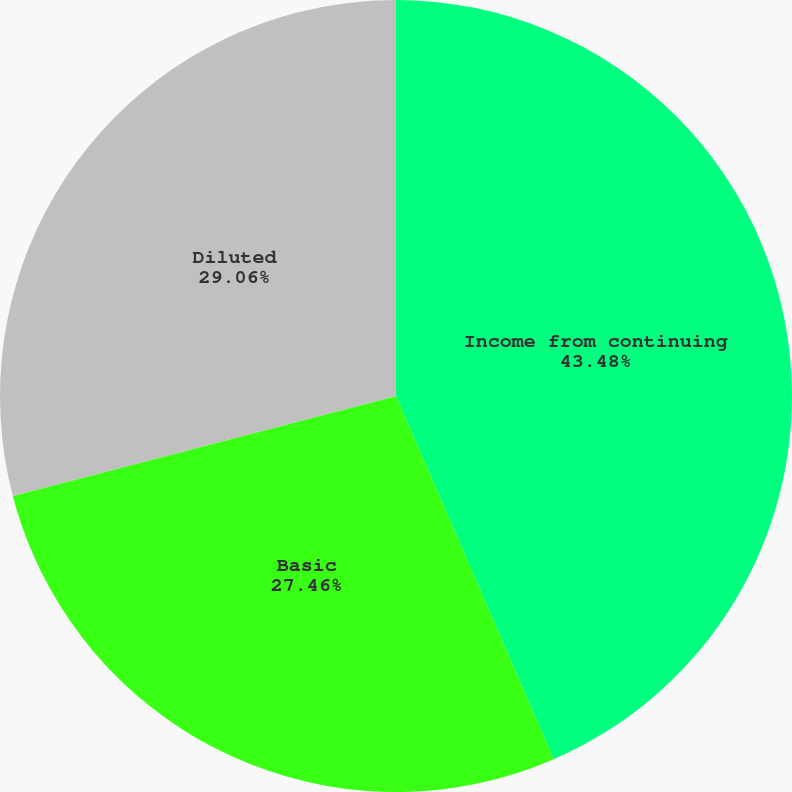<chart> <loc_0><loc_0><loc_500><loc_500><pie_chart><fcel>Income from continuing<fcel>Basic<fcel>Diluted<nl><fcel>43.48%<fcel>27.46%<fcel>29.06%<nl></chart> 